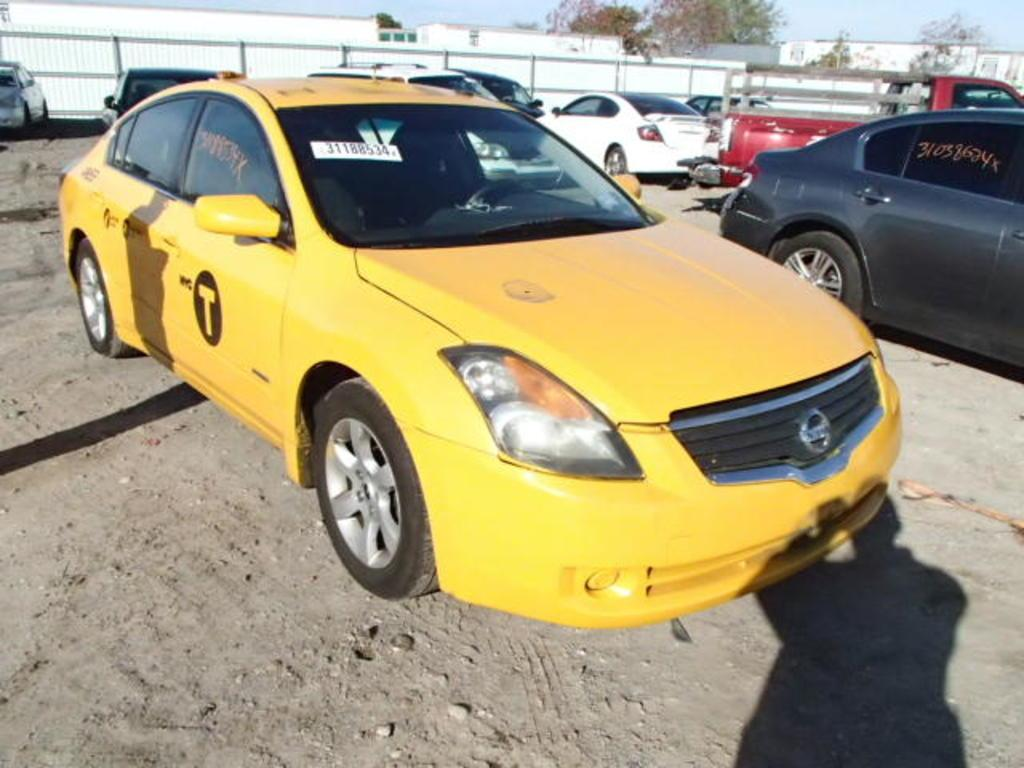<image>
Describe the image concisely. A New York yellow taxi cab numbered 31188534. 